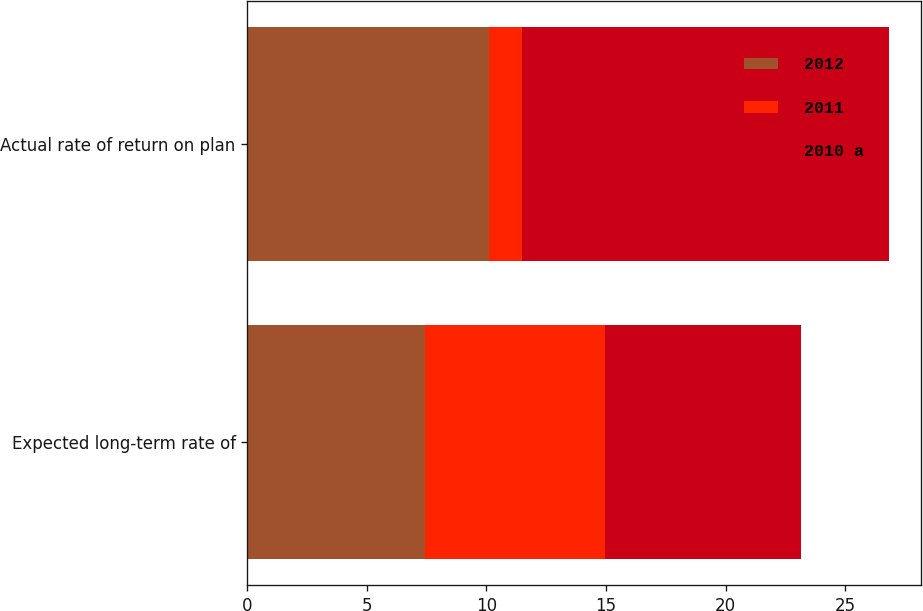Convert chart. <chart><loc_0><loc_0><loc_500><loc_500><stacked_bar_chart><ecel><fcel>Expected long-term rate of<fcel>Actual rate of return on plan<nl><fcel>2012<fcel>7.42<fcel>10.09<nl><fcel>2011<fcel>7.52<fcel>1.4<nl><fcel>2010 a<fcel>8.2<fcel>15.34<nl></chart> 